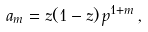Convert formula to latex. <formula><loc_0><loc_0><loc_500><loc_500>a _ { m } = z ( 1 - z ) \, p ^ { 1 + m } \, ,</formula> 